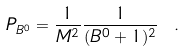Convert formula to latex. <formula><loc_0><loc_0><loc_500><loc_500>P _ { B ^ { 0 } } = \frac { 1 } { M ^ { 2 } } \frac { 1 } { ( B ^ { 0 } + 1 ) ^ { 2 } } \ .</formula> 